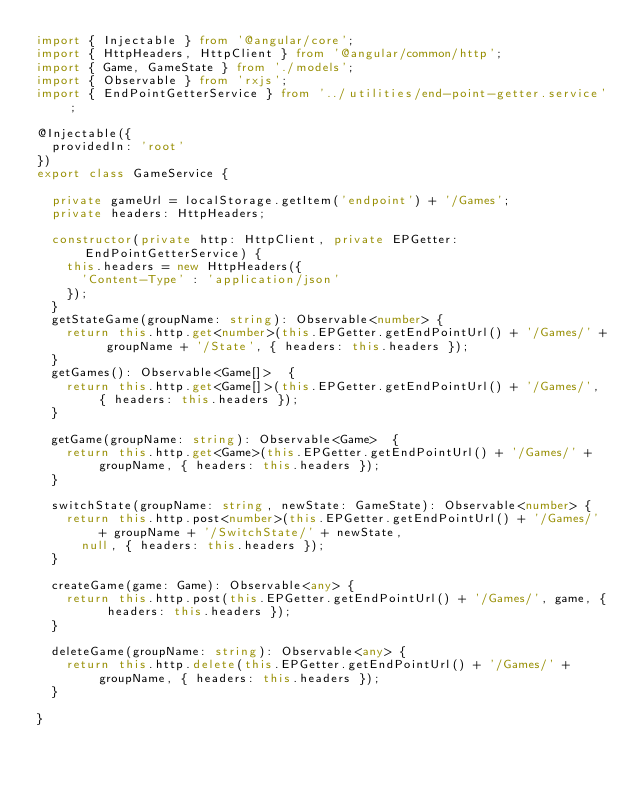Convert code to text. <code><loc_0><loc_0><loc_500><loc_500><_TypeScript_>import { Injectable } from '@angular/core';
import { HttpHeaders, HttpClient } from '@angular/common/http';
import { Game, GameState } from './models';
import { Observable } from 'rxjs';
import { EndPointGetterService } from '../utilities/end-point-getter.service';

@Injectable({
  providedIn: 'root'
})
export class GameService {

  private gameUrl = localStorage.getItem('endpoint') + '/Games';
  private headers: HttpHeaders;

  constructor(private http: HttpClient, private EPGetter: EndPointGetterService) {
    this.headers = new HttpHeaders({
      'Content-Type' : 'application/json'
    });
  }
  getStateGame(groupName: string): Observable<number> {
    return this.http.get<number>(this.EPGetter.getEndPointUrl() + '/Games/' + groupName + '/State', { headers: this.headers });
  }
  getGames(): Observable<Game[]>  {
    return this.http.get<Game[]>(this.EPGetter.getEndPointUrl() + '/Games/', { headers: this.headers });
  }

  getGame(groupName: string): Observable<Game>  {
    return this.http.get<Game>(this.EPGetter.getEndPointUrl() + '/Games/' + groupName, { headers: this.headers });
  }

  switchState(groupName: string, newState: GameState): Observable<number> {
    return this.http.post<number>(this.EPGetter.getEndPointUrl() + '/Games/' + groupName + '/SwitchState/' + newState,
      null, { headers: this.headers });
  }

  createGame(game: Game): Observable<any> {
    return this.http.post(this.EPGetter.getEndPointUrl() + '/Games/', game, { headers: this.headers });
  }

  deleteGame(groupName: string): Observable<any> {
    return this.http.delete(this.EPGetter.getEndPointUrl() + '/Games/' + groupName, { headers: this.headers });
  }

}
</code> 